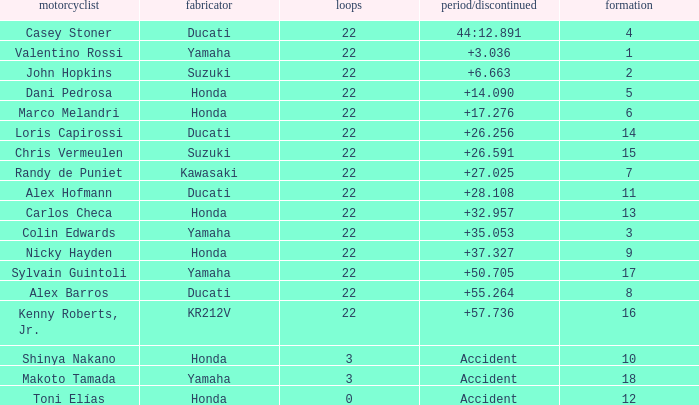What was the average amount of laps for competitors with a grid that was more than 11 and a Time/Retired of +28.108? None. 